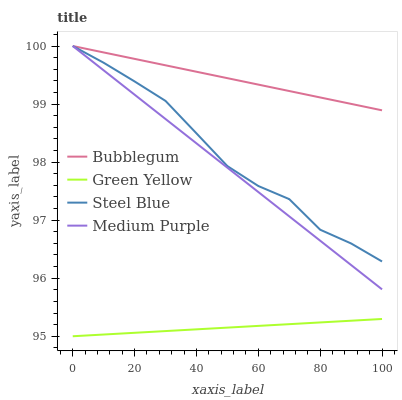Does Green Yellow have the minimum area under the curve?
Answer yes or no. Yes. Does Bubblegum have the maximum area under the curve?
Answer yes or no. Yes. Does Steel Blue have the minimum area under the curve?
Answer yes or no. No. Does Steel Blue have the maximum area under the curve?
Answer yes or no. No. Is Medium Purple the smoothest?
Answer yes or no. Yes. Is Steel Blue the roughest?
Answer yes or no. Yes. Is Green Yellow the smoothest?
Answer yes or no. No. Is Green Yellow the roughest?
Answer yes or no. No. Does Green Yellow have the lowest value?
Answer yes or no. Yes. Does Steel Blue have the lowest value?
Answer yes or no. No. Does Bubblegum have the highest value?
Answer yes or no. Yes. Does Green Yellow have the highest value?
Answer yes or no. No. Is Green Yellow less than Medium Purple?
Answer yes or no. Yes. Is Medium Purple greater than Green Yellow?
Answer yes or no. Yes. Does Steel Blue intersect Bubblegum?
Answer yes or no. Yes. Is Steel Blue less than Bubblegum?
Answer yes or no. No. Is Steel Blue greater than Bubblegum?
Answer yes or no. No. Does Green Yellow intersect Medium Purple?
Answer yes or no. No. 